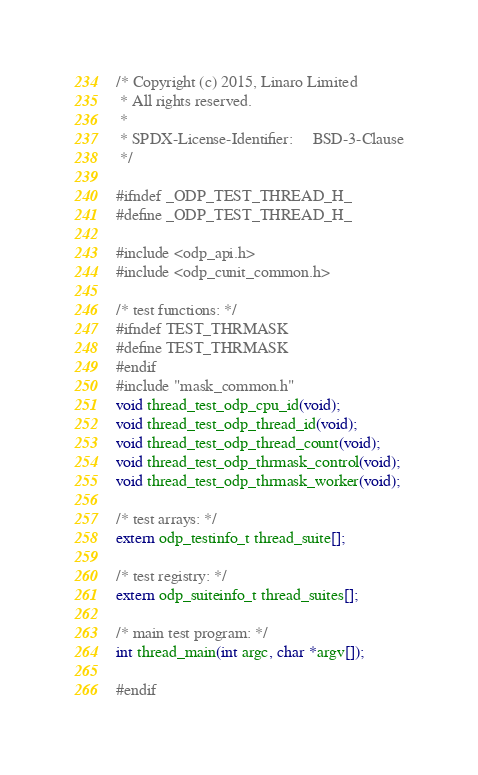<code> <loc_0><loc_0><loc_500><loc_500><_C_>/* Copyright (c) 2015, Linaro Limited
 * All rights reserved.
 *
 * SPDX-License-Identifier:     BSD-3-Clause
 */

#ifndef _ODP_TEST_THREAD_H_
#define _ODP_TEST_THREAD_H_

#include <odp_api.h>
#include <odp_cunit_common.h>

/* test functions: */
#ifndef TEST_THRMASK
#define TEST_THRMASK
#endif
#include "mask_common.h"
void thread_test_odp_cpu_id(void);
void thread_test_odp_thread_id(void);
void thread_test_odp_thread_count(void);
void thread_test_odp_thrmask_control(void);
void thread_test_odp_thrmask_worker(void);

/* test arrays: */
extern odp_testinfo_t thread_suite[];

/* test registry: */
extern odp_suiteinfo_t thread_suites[];

/* main test program: */
int thread_main(int argc, char *argv[]);

#endif
</code> 